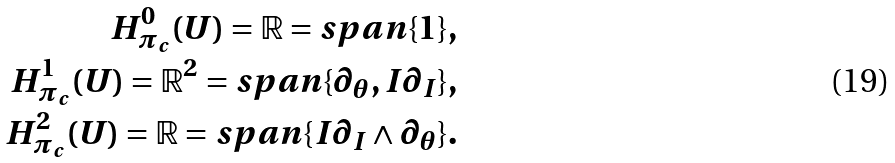<formula> <loc_0><loc_0><loc_500><loc_500>H _ { \pi _ { c } } ^ { 0 } ( U ) = { \mathbb { R } } = s p a n \{ 1 \} , \\ H _ { \pi _ { c } } ^ { 1 } ( U ) = { \mathbb { R } } ^ { 2 } = s p a n \{ \partial _ { \theta } , I \partial _ { I } \} , \\ H _ { \pi _ { c } } ^ { 2 } ( U ) = { \mathbb { R } } = s p a n \{ I \partial _ { I } \wedge \partial _ { \theta } \} .</formula> 